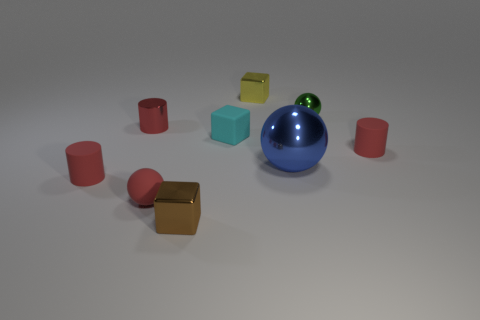Subtract all gray spheres. Subtract all green blocks. How many spheres are left? 3 Subtract all brown cylinders. How many brown spheres are left? 0 Add 8 large cyans. How many things exist? 0 Subtract all tiny blue metallic blocks. Subtract all cyan rubber blocks. How many objects are left? 8 Add 9 green metallic objects. How many green metallic objects are left? 10 Add 1 tiny cylinders. How many tiny cylinders exist? 4 Add 1 tiny objects. How many objects exist? 10 Subtract all cyan blocks. How many blocks are left? 2 Subtract all small red balls. How many balls are left? 2 Subtract 0 blue cylinders. How many objects are left? 9 